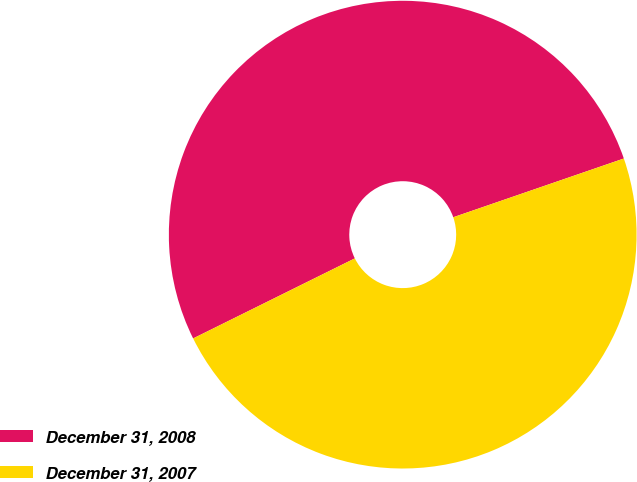Convert chart. <chart><loc_0><loc_0><loc_500><loc_500><pie_chart><fcel>December 31, 2008<fcel>December 31, 2007<nl><fcel>52.04%<fcel>47.96%<nl></chart> 